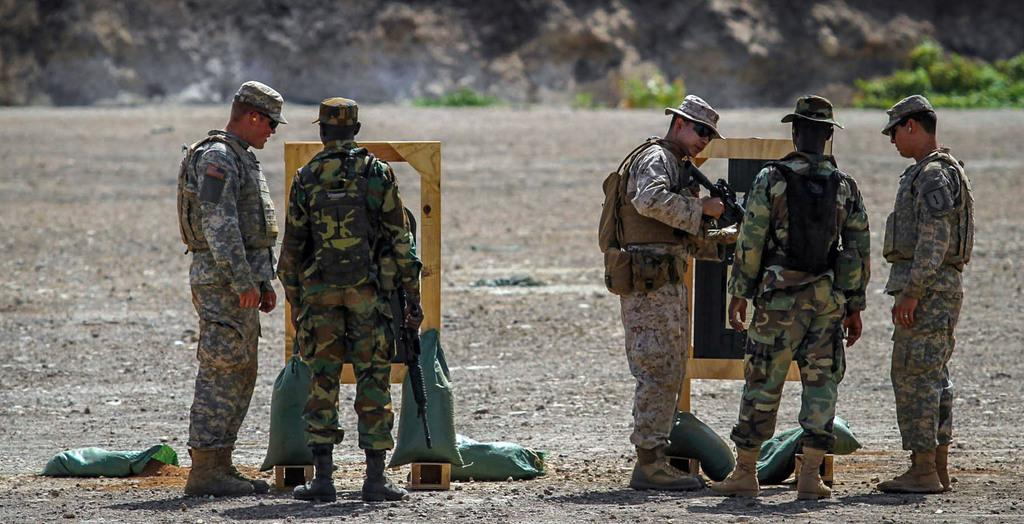How many people are in the image? There are five people in the image. What are the people wearing? The people are wearing uniforms. What are the people holding? The people are holding guns. What can be seen in the background of the image? There is a mountain in the background of the image. What type of fear is expressed by the people in the image? There is no indication of fear in the image, as the people are wearing uniforms and holding guns. 